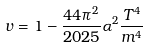<formula> <loc_0><loc_0><loc_500><loc_500>v = 1 - \frac { 4 4 \pi ^ { 2 } } { 2 0 2 5 } \alpha ^ { 2 } \frac { T ^ { 4 } } { m ^ { 4 } }</formula> 